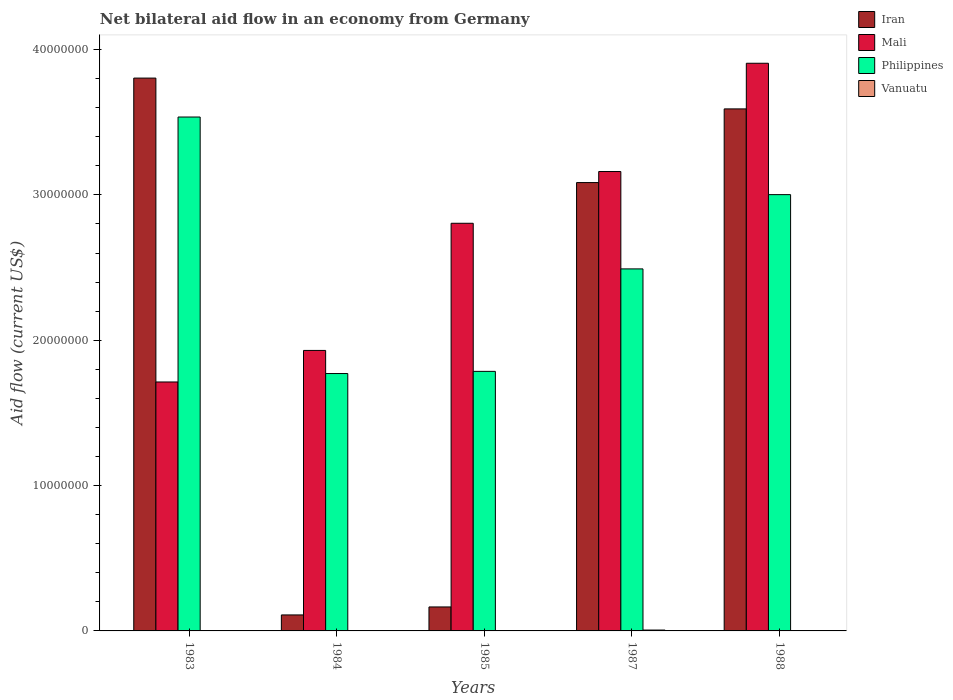How many different coloured bars are there?
Keep it short and to the point. 4. Are the number of bars on each tick of the X-axis equal?
Your response must be concise. Yes. In how many cases, is the number of bars for a given year not equal to the number of legend labels?
Your answer should be compact. 0. Across all years, what is the maximum net bilateral aid flow in Philippines?
Your answer should be very brief. 3.54e+07. Across all years, what is the minimum net bilateral aid flow in Philippines?
Offer a terse response. 1.77e+07. In which year was the net bilateral aid flow in Philippines maximum?
Give a very brief answer. 1983. In which year was the net bilateral aid flow in Mali minimum?
Offer a terse response. 1983. What is the total net bilateral aid flow in Mali in the graph?
Give a very brief answer. 1.35e+08. What is the difference between the net bilateral aid flow in Vanuatu in 1984 and that in 1987?
Keep it short and to the point. -4.00e+04. What is the difference between the net bilateral aid flow in Vanuatu in 1988 and the net bilateral aid flow in Mali in 1985?
Provide a succinct answer. -2.80e+07. What is the average net bilateral aid flow in Vanuatu per year?
Your answer should be compact. 2.20e+04. In the year 1987, what is the difference between the net bilateral aid flow in Iran and net bilateral aid flow in Mali?
Offer a terse response. -7.60e+05. In how many years, is the net bilateral aid flow in Philippines greater than 26000000 US$?
Your answer should be compact. 2. Is the net bilateral aid flow in Philippines in 1983 less than that in 1985?
Make the answer very short. No. Is the difference between the net bilateral aid flow in Iran in 1985 and 1988 greater than the difference between the net bilateral aid flow in Mali in 1985 and 1988?
Provide a succinct answer. No. What is the difference between the highest and the second highest net bilateral aid flow in Mali?
Offer a terse response. 7.45e+06. What is the difference between the highest and the lowest net bilateral aid flow in Philippines?
Keep it short and to the point. 1.76e+07. What does the 1st bar from the left in 1985 represents?
Make the answer very short. Iran. Is it the case that in every year, the sum of the net bilateral aid flow in Iran and net bilateral aid flow in Philippines is greater than the net bilateral aid flow in Vanuatu?
Offer a terse response. Yes. How many bars are there?
Provide a short and direct response. 20. Are all the bars in the graph horizontal?
Your answer should be compact. No. Are the values on the major ticks of Y-axis written in scientific E-notation?
Keep it short and to the point. No. How many legend labels are there?
Your response must be concise. 4. What is the title of the graph?
Your answer should be compact. Net bilateral aid flow in an economy from Germany. What is the label or title of the Y-axis?
Ensure brevity in your answer.  Aid flow (current US$). What is the Aid flow (current US$) in Iran in 1983?
Your answer should be compact. 3.80e+07. What is the Aid flow (current US$) of Mali in 1983?
Offer a terse response. 1.71e+07. What is the Aid flow (current US$) of Philippines in 1983?
Provide a succinct answer. 3.54e+07. What is the Aid flow (current US$) of Iran in 1984?
Offer a terse response. 1.10e+06. What is the Aid flow (current US$) in Mali in 1984?
Offer a terse response. 1.93e+07. What is the Aid flow (current US$) in Philippines in 1984?
Your response must be concise. 1.77e+07. What is the Aid flow (current US$) of Iran in 1985?
Your answer should be compact. 1.65e+06. What is the Aid flow (current US$) of Mali in 1985?
Your answer should be very brief. 2.80e+07. What is the Aid flow (current US$) of Philippines in 1985?
Your response must be concise. 1.79e+07. What is the Aid flow (current US$) of Iran in 1987?
Your answer should be very brief. 3.08e+07. What is the Aid flow (current US$) in Mali in 1987?
Offer a very short reply. 3.16e+07. What is the Aid flow (current US$) in Philippines in 1987?
Offer a terse response. 2.49e+07. What is the Aid flow (current US$) of Vanuatu in 1987?
Provide a succinct answer. 6.00e+04. What is the Aid flow (current US$) in Iran in 1988?
Keep it short and to the point. 3.59e+07. What is the Aid flow (current US$) in Mali in 1988?
Offer a very short reply. 3.91e+07. What is the Aid flow (current US$) in Philippines in 1988?
Keep it short and to the point. 3.00e+07. Across all years, what is the maximum Aid flow (current US$) in Iran?
Keep it short and to the point. 3.80e+07. Across all years, what is the maximum Aid flow (current US$) in Mali?
Provide a short and direct response. 3.91e+07. Across all years, what is the maximum Aid flow (current US$) in Philippines?
Keep it short and to the point. 3.54e+07. Across all years, what is the maximum Aid flow (current US$) in Vanuatu?
Your answer should be very brief. 6.00e+04. Across all years, what is the minimum Aid flow (current US$) of Iran?
Provide a succinct answer. 1.10e+06. Across all years, what is the minimum Aid flow (current US$) of Mali?
Your answer should be very brief. 1.71e+07. Across all years, what is the minimum Aid flow (current US$) of Philippines?
Make the answer very short. 1.77e+07. Across all years, what is the minimum Aid flow (current US$) of Vanuatu?
Provide a short and direct response. 10000. What is the total Aid flow (current US$) of Iran in the graph?
Provide a succinct answer. 1.08e+08. What is the total Aid flow (current US$) of Mali in the graph?
Give a very brief answer. 1.35e+08. What is the total Aid flow (current US$) in Philippines in the graph?
Your answer should be compact. 1.26e+08. What is the difference between the Aid flow (current US$) in Iran in 1983 and that in 1984?
Ensure brevity in your answer.  3.69e+07. What is the difference between the Aid flow (current US$) in Mali in 1983 and that in 1984?
Your answer should be compact. -2.17e+06. What is the difference between the Aid flow (current US$) in Philippines in 1983 and that in 1984?
Your answer should be compact. 1.76e+07. What is the difference between the Aid flow (current US$) in Iran in 1983 and that in 1985?
Give a very brief answer. 3.64e+07. What is the difference between the Aid flow (current US$) of Mali in 1983 and that in 1985?
Provide a succinct answer. -1.09e+07. What is the difference between the Aid flow (current US$) of Philippines in 1983 and that in 1985?
Ensure brevity in your answer.  1.75e+07. What is the difference between the Aid flow (current US$) of Vanuatu in 1983 and that in 1985?
Your answer should be very brief. 0. What is the difference between the Aid flow (current US$) in Iran in 1983 and that in 1987?
Offer a very short reply. 7.19e+06. What is the difference between the Aid flow (current US$) in Mali in 1983 and that in 1987?
Your response must be concise. -1.45e+07. What is the difference between the Aid flow (current US$) in Philippines in 1983 and that in 1987?
Your answer should be compact. 1.04e+07. What is the difference between the Aid flow (current US$) in Vanuatu in 1983 and that in 1987?
Offer a terse response. -5.00e+04. What is the difference between the Aid flow (current US$) of Iran in 1983 and that in 1988?
Offer a terse response. 2.12e+06. What is the difference between the Aid flow (current US$) in Mali in 1983 and that in 1988?
Your response must be concise. -2.19e+07. What is the difference between the Aid flow (current US$) of Philippines in 1983 and that in 1988?
Give a very brief answer. 5.34e+06. What is the difference between the Aid flow (current US$) in Vanuatu in 1983 and that in 1988?
Keep it short and to the point. 0. What is the difference between the Aid flow (current US$) in Iran in 1984 and that in 1985?
Make the answer very short. -5.50e+05. What is the difference between the Aid flow (current US$) in Mali in 1984 and that in 1985?
Your response must be concise. -8.75e+06. What is the difference between the Aid flow (current US$) in Vanuatu in 1984 and that in 1985?
Offer a very short reply. 10000. What is the difference between the Aid flow (current US$) of Iran in 1984 and that in 1987?
Provide a succinct answer. -2.98e+07. What is the difference between the Aid flow (current US$) of Mali in 1984 and that in 1987?
Ensure brevity in your answer.  -1.23e+07. What is the difference between the Aid flow (current US$) of Philippines in 1984 and that in 1987?
Provide a succinct answer. -7.20e+06. What is the difference between the Aid flow (current US$) of Vanuatu in 1984 and that in 1987?
Give a very brief answer. -4.00e+04. What is the difference between the Aid flow (current US$) in Iran in 1984 and that in 1988?
Offer a terse response. -3.48e+07. What is the difference between the Aid flow (current US$) of Mali in 1984 and that in 1988?
Ensure brevity in your answer.  -1.98e+07. What is the difference between the Aid flow (current US$) of Philippines in 1984 and that in 1988?
Ensure brevity in your answer.  -1.23e+07. What is the difference between the Aid flow (current US$) of Iran in 1985 and that in 1987?
Ensure brevity in your answer.  -2.92e+07. What is the difference between the Aid flow (current US$) in Mali in 1985 and that in 1987?
Your response must be concise. -3.56e+06. What is the difference between the Aid flow (current US$) of Philippines in 1985 and that in 1987?
Provide a succinct answer. -7.05e+06. What is the difference between the Aid flow (current US$) of Iran in 1985 and that in 1988?
Keep it short and to the point. -3.43e+07. What is the difference between the Aid flow (current US$) in Mali in 1985 and that in 1988?
Your answer should be compact. -1.10e+07. What is the difference between the Aid flow (current US$) in Philippines in 1985 and that in 1988?
Offer a very short reply. -1.22e+07. What is the difference between the Aid flow (current US$) in Iran in 1987 and that in 1988?
Ensure brevity in your answer.  -5.07e+06. What is the difference between the Aid flow (current US$) in Mali in 1987 and that in 1988?
Offer a terse response. -7.45e+06. What is the difference between the Aid flow (current US$) in Philippines in 1987 and that in 1988?
Keep it short and to the point. -5.11e+06. What is the difference between the Aid flow (current US$) of Vanuatu in 1987 and that in 1988?
Offer a very short reply. 5.00e+04. What is the difference between the Aid flow (current US$) in Iran in 1983 and the Aid flow (current US$) in Mali in 1984?
Provide a short and direct response. 1.87e+07. What is the difference between the Aid flow (current US$) in Iran in 1983 and the Aid flow (current US$) in Philippines in 1984?
Offer a very short reply. 2.03e+07. What is the difference between the Aid flow (current US$) of Iran in 1983 and the Aid flow (current US$) of Vanuatu in 1984?
Offer a very short reply. 3.80e+07. What is the difference between the Aid flow (current US$) of Mali in 1983 and the Aid flow (current US$) of Philippines in 1984?
Offer a very short reply. -5.80e+05. What is the difference between the Aid flow (current US$) of Mali in 1983 and the Aid flow (current US$) of Vanuatu in 1984?
Your response must be concise. 1.71e+07. What is the difference between the Aid flow (current US$) in Philippines in 1983 and the Aid flow (current US$) in Vanuatu in 1984?
Offer a terse response. 3.53e+07. What is the difference between the Aid flow (current US$) of Iran in 1983 and the Aid flow (current US$) of Mali in 1985?
Your answer should be very brief. 9.99e+06. What is the difference between the Aid flow (current US$) of Iran in 1983 and the Aid flow (current US$) of Philippines in 1985?
Provide a short and direct response. 2.02e+07. What is the difference between the Aid flow (current US$) of Iran in 1983 and the Aid flow (current US$) of Vanuatu in 1985?
Offer a very short reply. 3.80e+07. What is the difference between the Aid flow (current US$) of Mali in 1983 and the Aid flow (current US$) of Philippines in 1985?
Provide a short and direct response. -7.30e+05. What is the difference between the Aid flow (current US$) in Mali in 1983 and the Aid flow (current US$) in Vanuatu in 1985?
Ensure brevity in your answer.  1.71e+07. What is the difference between the Aid flow (current US$) in Philippines in 1983 and the Aid flow (current US$) in Vanuatu in 1985?
Your answer should be compact. 3.54e+07. What is the difference between the Aid flow (current US$) in Iran in 1983 and the Aid flow (current US$) in Mali in 1987?
Offer a terse response. 6.43e+06. What is the difference between the Aid flow (current US$) in Iran in 1983 and the Aid flow (current US$) in Philippines in 1987?
Keep it short and to the point. 1.31e+07. What is the difference between the Aid flow (current US$) in Iran in 1983 and the Aid flow (current US$) in Vanuatu in 1987?
Keep it short and to the point. 3.80e+07. What is the difference between the Aid flow (current US$) in Mali in 1983 and the Aid flow (current US$) in Philippines in 1987?
Provide a succinct answer. -7.78e+06. What is the difference between the Aid flow (current US$) of Mali in 1983 and the Aid flow (current US$) of Vanuatu in 1987?
Provide a short and direct response. 1.71e+07. What is the difference between the Aid flow (current US$) of Philippines in 1983 and the Aid flow (current US$) of Vanuatu in 1987?
Your answer should be very brief. 3.53e+07. What is the difference between the Aid flow (current US$) in Iran in 1983 and the Aid flow (current US$) in Mali in 1988?
Ensure brevity in your answer.  -1.02e+06. What is the difference between the Aid flow (current US$) of Iran in 1983 and the Aid flow (current US$) of Philippines in 1988?
Your answer should be very brief. 8.02e+06. What is the difference between the Aid flow (current US$) of Iran in 1983 and the Aid flow (current US$) of Vanuatu in 1988?
Your response must be concise. 3.80e+07. What is the difference between the Aid flow (current US$) of Mali in 1983 and the Aid flow (current US$) of Philippines in 1988?
Give a very brief answer. -1.29e+07. What is the difference between the Aid flow (current US$) in Mali in 1983 and the Aid flow (current US$) in Vanuatu in 1988?
Offer a very short reply. 1.71e+07. What is the difference between the Aid flow (current US$) in Philippines in 1983 and the Aid flow (current US$) in Vanuatu in 1988?
Keep it short and to the point. 3.54e+07. What is the difference between the Aid flow (current US$) of Iran in 1984 and the Aid flow (current US$) of Mali in 1985?
Your response must be concise. -2.70e+07. What is the difference between the Aid flow (current US$) in Iran in 1984 and the Aid flow (current US$) in Philippines in 1985?
Your answer should be compact. -1.68e+07. What is the difference between the Aid flow (current US$) of Iran in 1984 and the Aid flow (current US$) of Vanuatu in 1985?
Provide a succinct answer. 1.09e+06. What is the difference between the Aid flow (current US$) in Mali in 1984 and the Aid flow (current US$) in Philippines in 1985?
Your answer should be compact. 1.44e+06. What is the difference between the Aid flow (current US$) of Mali in 1984 and the Aid flow (current US$) of Vanuatu in 1985?
Provide a short and direct response. 1.93e+07. What is the difference between the Aid flow (current US$) in Philippines in 1984 and the Aid flow (current US$) in Vanuatu in 1985?
Give a very brief answer. 1.77e+07. What is the difference between the Aid flow (current US$) of Iran in 1984 and the Aid flow (current US$) of Mali in 1987?
Provide a short and direct response. -3.05e+07. What is the difference between the Aid flow (current US$) of Iran in 1984 and the Aid flow (current US$) of Philippines in 1987?
Your response must be concise. -2.38e+07. What is the difference between the Aid flow (current US$) of Iran in 1984 and the Aid flow (current US$) of Vanuatu in 1987?
Your response must be concise. 1.04e+06. What is the difference between the Aid flow (current US$) of Mali in 1984 and the Aid flow (current US$) of Philippines in 1987?
Your answer should be compact. -5.61e+06. What is the difference between the Aid flow (current US$) of Mali in 1984 and the Aid flow (current US$) of Vanuatu in 1987?
Your answer should be very brief. 1.92e+07. What is the difference between the Aid flow (current US$) in Philippines in 1984 and the Aid flow (current US$) in Vanuatu in 1987?
Offer a terse response. 1.76e+07. What is the difference between the Aid flow (current US$) in Iran in 1984 and the Aid flow (current US$) in Mali in 1988?
Ensure brevity in your answer.  -3.80e+07. What is the difference between the Aid flow (current US$) in Iran in 1984 and the Aid flow (current US$) in Philippines in 1988?
Ensure brevity in your answer.  -2.89e+07. What is the difference between the Aid flow (current US$) of Iran in 1984 and the Aid flow (current US$) of Vanuatu in 1988?
Ensure brevity in your answer.  1.09e+06. What is the difference between the Aid flow (current US$) of Mali in 1984 and the Aid flow (current US$) of Philippines in 1988?
Give a very brief answer. -1.07e+07. What is the difference between the Aid flow (current US$) of Mali in 1984 and the Aid flow (current US$) of Vanuatu in 1988?
Offer a very short reply. 1.93e+07. What is the difference between the Aid flow (current US$) in Philippines in 1984 and the Aid flow (current US$) in Vanuatu in 1988?
Offer a terse response. 1.77e+07. What is the difference between the Aid flow (current US$) in Iran in 1985 and the Aid flow (current US$) in Mali in 1987?
Offer a terse response. -3.00e+07. What is the difference between the Aid flow (current US$) in Iran in 1985 and the Aid flow (current US$) in Philippines in 1987?
Make the answer very short. -2.33e+07. What is the difference between the Aid flow (current US$) of Iran in 1985 and the Aid flow (current US$) of Vanuatu in 1987?
Provide a succinct answer. 1.59e+06. What is the difference between the Aid flow (current US$) of Mali in 1985 and the Aid flow (current US$) of Philippines in 1987?
Keep it short and to the point. 3.14e+06. What is the difference between the Aid flow (current US$) of Mali in 1985 and the Aid flow (current US$) of Vanuatu in 1987?
Offer a very short reply. 2.80e+07. What is the difference between the Aid flow (current US$) of Philippines in 1985 and the Aid flow (current US$) of Vanuatu in 1987?
Your response must be concise. 1.78e+07. What is the difference between the Aid flow (current US$) of Iran in 1985 and the Aid flow (current US$) of Mali in 1988?
Make the answer very short. -3.74e+07. What is the difference between the Aid flow (current US$) in Iran in 1985 and the Aid flow (current US$) in Philippines in 1988?
Give a very brief answer. -2.84e+07. What is the difference between the Aid flow (current US$) in Iran in 1985 and the Aid flow (current US$) in Vanuatu in 1988?
Ensure brevity in your answer.  1.64e+06. What is the difference between the Aid flow (current US$) in Mali in 1985 and the Aid flow (current US$) in Philippines in 1988?
Keep it short and to the point. -1.97e+06. What is the difference between the Aid flow (current US$) in Mali in 1985 and the Aid flow (current US$) in Vanuatu in 1988?
Your answer should be very brief. 2.80e+07. What is the difference between the Aid flow (current US$) in Philippines in 1985 and the Aid flow (current US$) in Vanuatu in 1988?
Your response must be concise. 1.78e+07. What is the difference between the Aid flow (current US$) in Iran in 1987 and the Aid flow (current US$) in Mali in 1988?
Ensure brevity in your answer.  -8.21e+06. What is the difference between the Aid flow (current US$) of Iran in 1987 and the Aid flow (current US$) of Philippines in 1988?
Your answer should be very brief. 8.30e+05. What is the difference between the Aid flow (current US$) of Iran in 1987 and the Aid flow (current US$) of Vanuatu in 1988?
Your response must be concise. 3.08e+07. What is the difference between the Aid flow (current US$) of Mali in 1987 and the Aid flow (current US$) of Philippines in 1988?
Keep it short and to the point. 1.59e+06. What is the difference between the Aid flow (current US$) in Mali in 1987 and the Aid flow (current US$) in Vanuatu in 1988?
Offer a terse response. 3.16e+07. What is the difference between the Aid flow (current US$) in Philippines in 1987 and the Aid flow (current US$) in Vanuatu in 1988?
Your response must be concise. 2.49e+07. What is the average Aid flow (current US$) in Iran per year?
Keep it short and to the point. 2.15e+07. What is the average Aid flow (current US$) in Mali per year?
Provide a short and direct response. 2.70e+07. What is the average Aid flow (current US$) in Philippines per year?
Ensure brevity in your answer.  2.52e+07. What is the average Aid flow (current US$) in Vanuatu per year?
Make the answer very short. 2.20e+04. In the year 1983, what is the difference between the Aid flow (current US$) in Iran and Aid flow (current US$) in Mali?
Make the answer very short. 2.09e+07. In the year 1983, what is the difference between the Aid flow (current US$) of Iran and Aid flow (current US$) of Philippines?
Keep it short and to the point. 2.68e+06. In the year 1983, what is the difference between the Aid flow (current US$) of Iran and Aid flow (current US$) of Vanuatu?
Give a very brief answer. 3.80e+07. In the year 1983, what is the difference between the Aid flow (current US$) in Mali and Aid flow (current US$) in Philippines?
Give a very brief answer. -1.82e+07. In the year 1983, what is the difference between the Aid flow (current US$) in Mali and Aid flow (current US$) in Vanuatu?
Offer a terse response. 1.71e+07. In the year 1983, what is the difference between the Aid flow (current US$) in Philippines and Aid flow (current US$) in Vanuatu?
Give a very brief answer. 3.54e+07. In the year 1984, what is the difference between the Aid flow (current US$) of Iran and Aid flow (current US$) of Mali?
Provide a short and direct response. -1.82e+07. In the year 1984, what is the difference between the Aid flow (current US$) in Iran and Aid flow (current US$) in Philippines?
Make the answer very short. -1.66e+07. In the year 1984, what is the difference between the Aid flow (current US$) in Iran and Aid flow (current US$) in Vanuatu?
Give a very brief answer. 1.08e+06. In the year 1984, what is the difference between the Aid flow (current US$) of Mali and Aid flow (current US$) of Philippines?
Offer a terse response. 1.59e+06. In the year 1984, what is the difference between the Aid flow (current US$) of Mali and Aid flow (current US$) of Vanuatu?
Provide a succinct answer. 1.93e+07. In the year 1984, what is the difference between the Aid flow (current US$) of Philippines and Aid flow (current US$) of Vanuatu?
Provide a short and direct response. 1.77e+07. In the year 1985, what is the difference between the Aid flow (current US$) of Iran and Aid flow (current US$) of Mali?
Your answer should be compact. -2.64e+07. In the year 1985, what is the difference between the Aid flow (current US$) in Iran and Aid flow (current US$) in Philippines?
Offer a terse response. -1.62e+07. In the year 1985, what is the difference between the Aid flow (current US$) in Iran and Aid flow (current US$) in Vanuatu?
Your response must be concise. 1.64e+06. In the year 1985, what is the difference between the Aid flow (current US$) of Mali and Aid flow (current US$) of Philippines?
Provide a short and direct response. 1.02e+07. In the year 1985, what is the difference between the Aid flow (current US$) in Mali and Aid flow (current US$) in Vanuatu?
Your answer should be compact. 2.80e+07. In the year 1985, what is the difference between the Aid flow (current US$) in Philippines and Aid flow (current US$) in Vanuatu?
Keep it short and to the point. 1.78e+07. In the year 1987, what is the difference between the Aid flow (current US$) of Iran and Aid flow (current US$) of Mali?
Provide a short and direct response. -7.60e+05. In the year 1987, what is the difference between the Aid flow (current US$) of Iran and Aid flow (current US$) of Philippines?
Provide a short and direct response. 5.94e+06. In the year 1987, what is the difference between the Aid flow (current US$) of Iran and Aid flow (current US$) of Vanuatu?
Your response must be concise. 3.08e+07. In the year 1987, what is the difference between the Aid flow (current US$) in Mali and Aid flow (current US$) in Philippines?
Make the answer very short. 6.70e+06. In the year 1987, what is the difference between the Aid flow (current US$) of Mali and Aid flow (current US$) of Vanuatu?
Your response must be concise. 3.16e+07. In the year 1987, what is the difference between the Aid flow (current US$) in Philippines and Aid flow (current US$) in Vanuatu?
Give a very brief answer. 2.48e+07. In the year 1988, what is the difference between the Aid flow (current US$) of Iran and Aid flow (current US$) of Mali?
Give a very brief answer. -3.14e+06. In the year 1988, what is the difference between the Aid flow (current US$) of Iran and Aid flow (current US$) of Philippines?
Your answer should be compact. 5.90e+06. In the year 1988, what is the difference between the Aid flow (current US$) of Iran and Aid flow (current US$) of Vanuatu?
Give a very brief answer. 3.59e+07. In the year 1988, what is the difference between the Aid flow (current US$) of Mali and Aid flow (current US$) of Philippines?
Provide a short and direct response. 9.04e+06. In the year 1988, what is the difference between the Aid flow (current US$) of Mali and Aid flow (current US$) of Vanuatu?
Your answer should be very brief. 3.90e+07. In the year 1988, what is the difference between the Aid flow (current US$) in Philippines and Aid flow (current US$) in Vanuatu?
Ensure brevity in your answer.  3.00e+07. What is the ratio of the Aid flow (current US$) of Iran in 1983 to that in 1984?
Provide a succinct answer. 34.58. What is the ratio of the Aid flow (current US$) of Mali in 1983 to that in 1984?
Your response must be concise. 0.89. What is the ratio of the Aid flow (current US$) of Philippines in 1983 to that in 1984?
Give a very brief answer. 2. What is the ratio of the Aid flow (current US$) in Vanuatu in 1983 to that in 1984?
Your answer should be compact. 0.5. What is the ratio of the Aid flow (current US$) of Iran in 1983 to that in 1985?
Provide a succinct answer. 23.05. What is the ratio of the Aid flow (current US$) in Mali in 1983 to that in 1985?
Keep it short and to the point. 0.61. What is the ratio of the Aid flow (current US$) of Philippines in 1983 to that in 1985?
Your answer should be very brief. 1.98. What is the ratio of the Aid flow (current US$) of Iran in 1983 to that in 1987?
Give a very brief answer. 1.23. What is the ratio of the Aid flow (current US$) in Mali in 1983 to that in 1987?
Provide a succinct answer. 0.54. What is the ratio of the Aid flow (current US$) of Philippines in 1983 to that in 1987?
Ensure brevity in your answer.  1.42. What is the ratio of the Aid flow (current US$) in Iran in 1983 to that in 1988?
Offer a terse response. 1.06. What is the ratio of the Aid flow (current US$) in Mali in 1983 to that in 1988?
Ensure brevity in your answer.  0.44. What is the ratio of the Aid flow (current US$) in Philippines in 1983 to that in 1988?
Keep it short and to the point. 1.18. What is the ratio of the Aid flow (current US$) of Vanuatu in 1983 to that in 1988?
Give a very brief answer. 1. What is the ratio of the Aid flow (current US$) of Mali in 1984 to that in 1985?
Give a very brief answer. 0.69. What is the ratio of the Aid flow (current US$) in Philippines in 1984 to that in 1985?
Your answer should be compact. 0.99. What is the ratio of the Aid flow (current US$) in Vanuatu in 1984 to that in 1985?
Give a very brief answer. 2. What is the ratio of the Aid flow (current US$) of Iran in 1984 to that in 1987?
Offer a very short reply. 0.04. What is the ratio of the Aid flow (current US$) in Mali in 1984 to that in 1987?
Offer a very short reply. 0.61. What is the ratio of the Aid flow (current US$) of Philippines in 1984 to that in 1987?
Offer a very short reply. 0.71. What is the ratio of the Aid flow (current US$) in Vanuatu in 1984 to that in 1987?
Offer a very short reply. 0.33. What is the ratio of the Aid flow (current US$) of Iran in 1984 to that in 1988?
Ensure brevity in your answer.  0.03. What is the ratio of the Aid flow (current US$) of Mali in 1984 to that in 1988?
Provide a short and direct response. 0.49. What is the ratio of the Aid flow (current US$) in Philippines in 1984 to that in 1988?
Keep it short and to the point. 0.59. What is the ratio of the Aid flow (current US$) of Vanuatu in 1984 to that in 1988?
Provide a short and direct response. 2. What is the ratio of the Aid flow (current US$) in Iran in 1985 to that in 1987?
Your response must be concise. 0.05. What is the ratio of the Aid flow (current US$) of Mali in 1985 to that in 1987?
Your answer should be compact. 0.89. What is the ratio of the Aid flow (current US$) in Philippines in 1985 to that in 1987?
Make the answer very short. 0.72. What is the ratio of the Aid flow (current US$) in Iran in 1985 to that in 1988?
Offer a very short reply. 0.05. What is the ratio of the Aid flow (current US$) of Mali in 1985 to that in 1988?
Provide a succinct answer. 0.72. What is the ratio of the Aid flow (current US$) of Philippines in 1985 to that in 1988?
Offer a terse response. 0.59. What is the ratio of the Aid flow (current US$) in Vanuatu in 1985 to that in 1988?
Your response must be concise. 1. What is the ratio of the Aid flow (current US$) in Iran in 1987 to that in 1988?
Offer a very short reply. 0.86. What is the ratio of the Aid flow (current US$) in Mali in 1987 to that in 1988?
Your response must be concise. 0.81. What is the ratio of the Aid flow (current US$) of Philippines in 1987 to that in 1988?
Keep it short and to the point. 0.83. What is the difference between the highest and the second highest Aid flow (current US$) of Iran?
Your answer should be very brief. 2.12e+06. What is the difference between the highest and the second highest Aid flow (current US$) of Mali?
Your answer should be very brief. 7.45e+06. What is the difference between the highest and the second highest Aid flow (current US$) in Philippines?
Make the answer very short. 5.34e+06. What is the difference between the highest and the second highest Aid flow (current US$) in Vanuatu?
Offer a terse response. 4.00e+04. What is the difference between the highest and the lowest Aid flow (current US$) of Iran?
Ensure brevity in your answer.  3.69e+07. What is the difference between the highest and the lowest Aid flow (current US$) in Mali?
Provide a succinct answer. 2.19e+07. What is the difference between the highest and the lowest Aid flow (current US$) in Philippines?
Make the answer very short. 1.76e+07. 